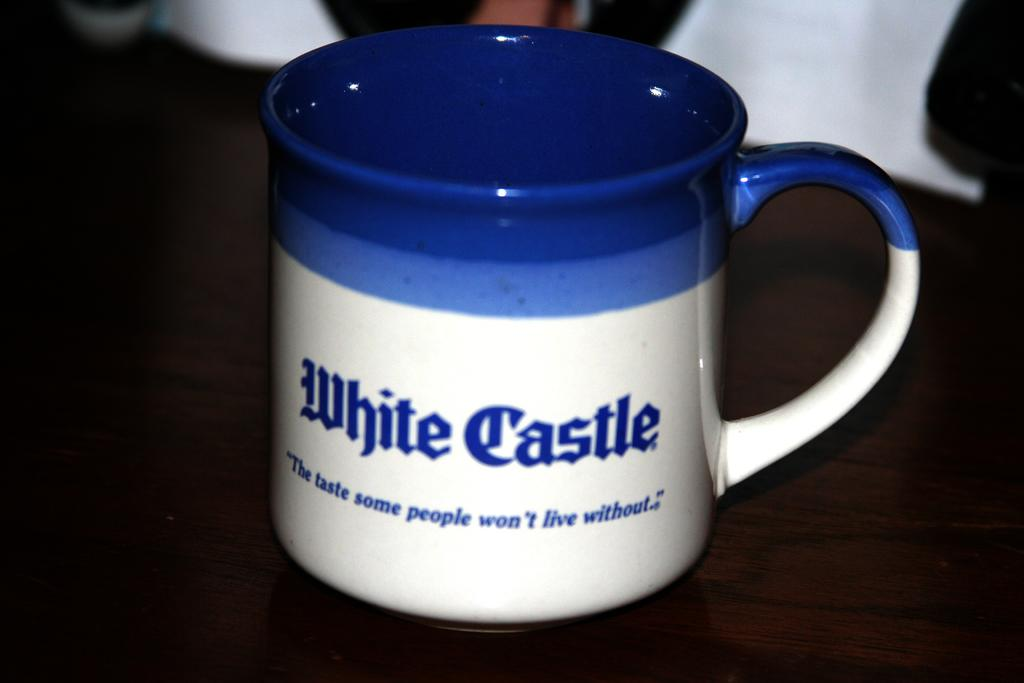<image>
Render a clear and concise summary of the photo. a coffee cuo from the business white castle 